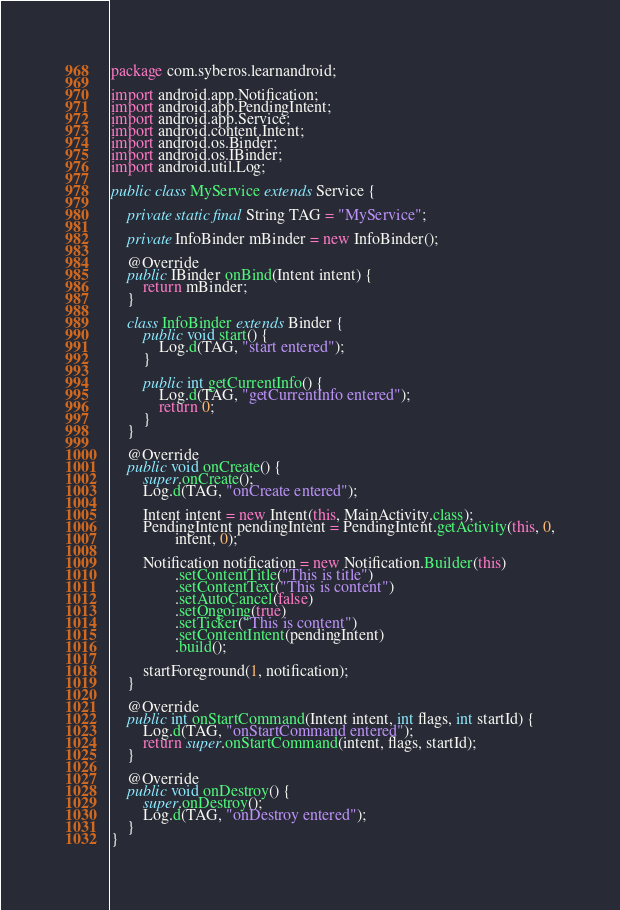Convert code to text. <code><loc_0><loc_0><loc_500><loc_500><_Java_>package com.syberos.learnandroid;

import android.app.Notification;
import android.app.PendingIntent;
import android.app.Service;
import android.content.Intent;
import android.os.Binder;
import android.os.IBinder;
import android.util.Log;

public class MyService extends Service {

    private static final String TAG = "MyService";

    private InfoBinder mBinder = new InfoBinder();

    @Override
    public IBinder onBind(Intent intent) {
        return mBinder;
    }

    class InfoBinder extends Binder {
        public void start() {
            Log.d(TAG, "start entered");
        }

        public int getCurrentInfo() {
            Log.d(TAG, "getCurrentInfo entered");
            return 0;
        }
    }

    @Override
    public void onCreate() {
        super.onCreate();
        Log.d(TAG, "onCreate entered");

        Intent intent = new Intent(this, MainActivity.class);
        PendingIntent pendingIntent = PendingIntent.getActivity(this, 0,
                intent, 0);

        Notification notification = new Notification.Builder(this)
                .setContentTitle("This is title")
                .setContentText("This is content")
                .setAutoCancel(false)
                .setOngoing(true)
                .setTicker("This is content")
                .setContentIntent(pendingIntent)
                .build();

        startForeground(1, notification);
    }

    @Override
    public int onStartCommand(Intent intent, int flags, int startId) {
        Log.d(TAG, "onStartCommand entered");
        return super.onStartCommand(intent, flags, startId);
    }

    @Override
    public void onDestroy() {
        super.onDestroy();
        Log.d(TAG, "onDestroy entered");
    }
}
</code> 